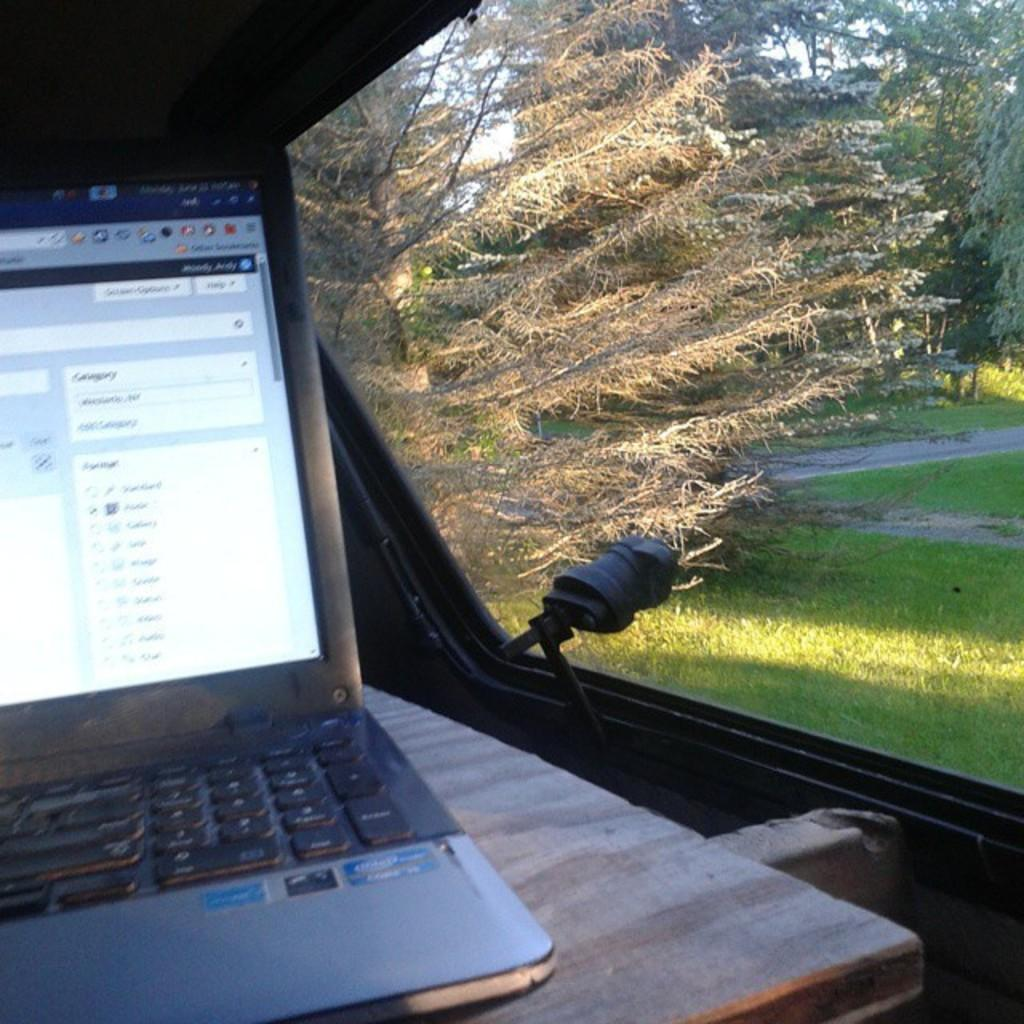What electronic device is on the table in the image? There is a laptop on the table in the image. What can be seen through the window in the image? There is a window in the image, and outside the window, the ground is covered with grass and there are many trees visible. What shape is the parcel that the person is playing with in the image? There is no parcel or person playing in the image. The image features a laptop on a table and a view outside a window with grass and trees. 